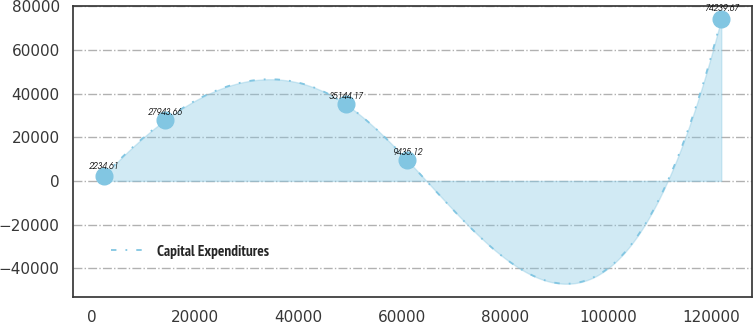Convert chart to OTSL. <chart><loc_0><loc_0><loc_500><loc_500><line_chart><ecel><fcel>Capital Expenditures<nl><fcel>2295.75<fcel>2234.61<nl><fcel>14252<fcel>27943.7<nl><fcel>49121.2<fcel>35144.2<nl><fcel>61077.4<fcel>9435.12<nl><fcel>121858<fcel>74239.7<nl></chart> 